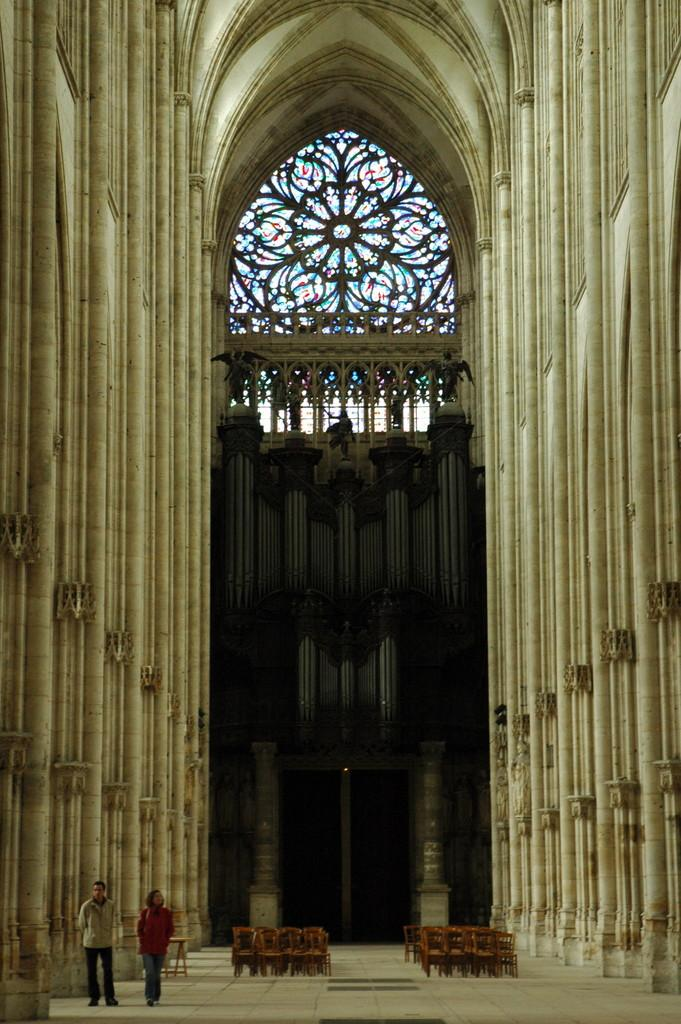What is the perspective of the image? The image is taken from inside. How many people are visible in the image? There are two people standing in the image. Where are the people standing? The people are standing on the floor. Can you describe the arrangement of furniture in the image? There are chairs arranged in the image. What can be seen in the background of the image? There are pillars and windows in the background of the image. What time of day is it in the image, based on the sound of bells? There are no bells present in the image, so we cannot determine the time of day based on their sound. 